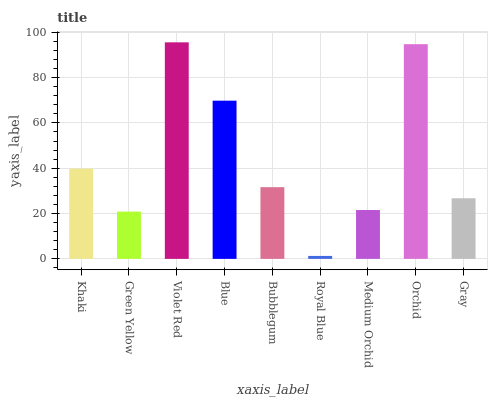Is Green Yellow the minimum?
Answer yes or no. No. Is Green Yellow the maximum?
Answer yes or no. No. Is Khaki greater than Green Yellow?
Answer yes or no. Yes. Is Green Yellow less than Khaki?
Answer yes or no. Yes. Is Green Yellow greater than Khaki?
Answer yes or no. No. Is Khaki less than Green Yellow?
Answer yes or no. No. Is Bubblegum the high median?
Answer yes or no. Yes. Is Bubblegum the low median?
Answer yes or no. Yes. Is Gray the high median?
Answer yes or no. No. Is Royal Blue the low median?
Answer yes or no. No. 